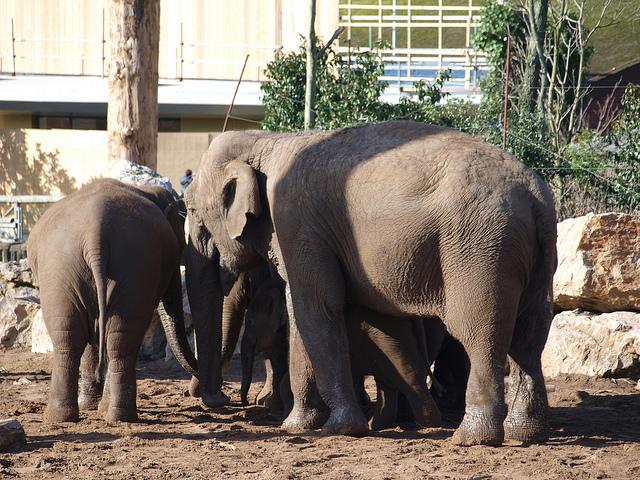What are they eating?
Give a very brief answer. Grass. Do you see large boulders?
Concise answer only. Yes. Is there a baby elephant?
Write a very short answer. Yes. Are the elephants in a hurry?
Short answer required. No. Is this elephant in the wild?
Keep it brief. No. Is the area clean or dirty?
Answer briefly. Dirty. What is here?
Short answer required. Elephants. 